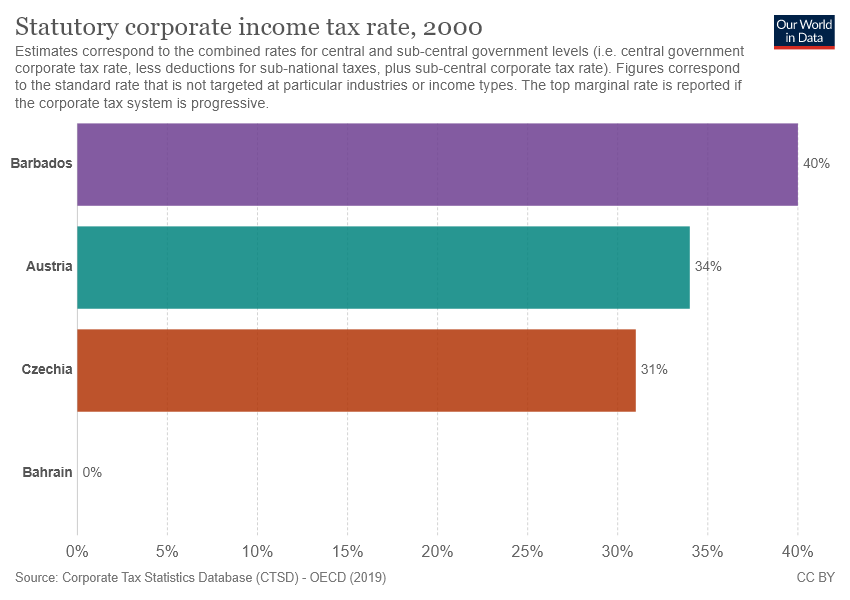Outline some significant characteristics in this image. Bahrain is a country that is 0%. The largest and smallest bar have a significant difference of 40. 